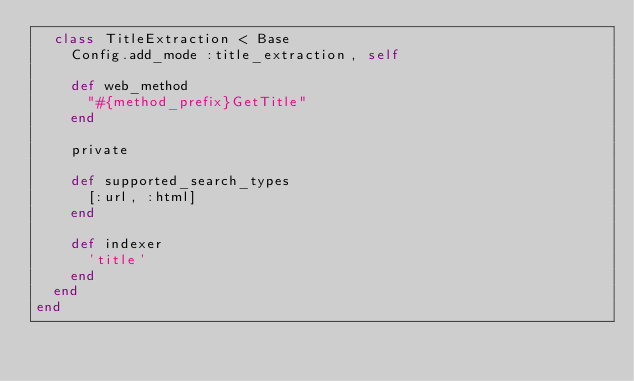<code> <loc_0><loc_0><loc_500><loc_500><_Ruby_>  class TitleExtraction < Base
    Config.add_mode :title_extraction, self

    def web_method
      "#{method_prefix}GetTitle"
    end

    private

    def supported_search_types
      [:url, :html]
    end

    def indexer
      'title'
    end
  end
end
</code> 